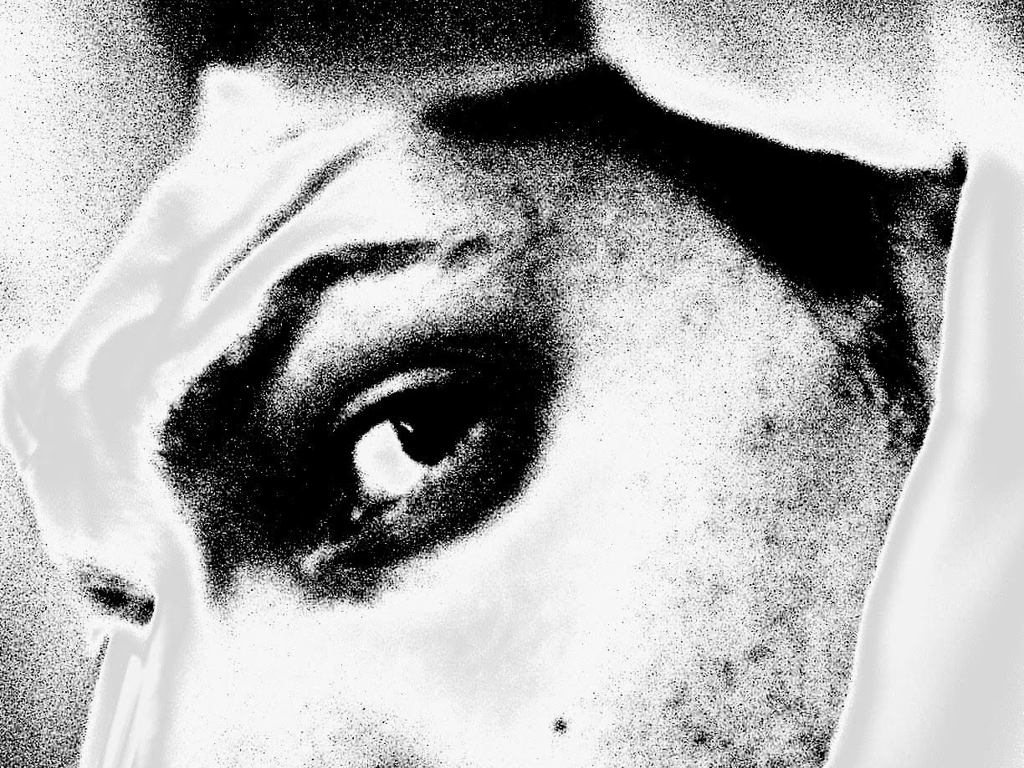What artistic techniques are evident in this image? Artistic techniques used include high-contrast lighting and a grainy texture which accentuate the details, such as the lines of the skin and the distinct iris pattern. The close-up composition and abstraction add to its artistic appeal. Could this image be part of a larger narrative or story? Absolutely, the image could signify a moment of revelation or discovery. Its intense and intimate portrayal of the eye could serve as a narrative device to offer a glimpse into a character's soul or hint at underlying secrets. 